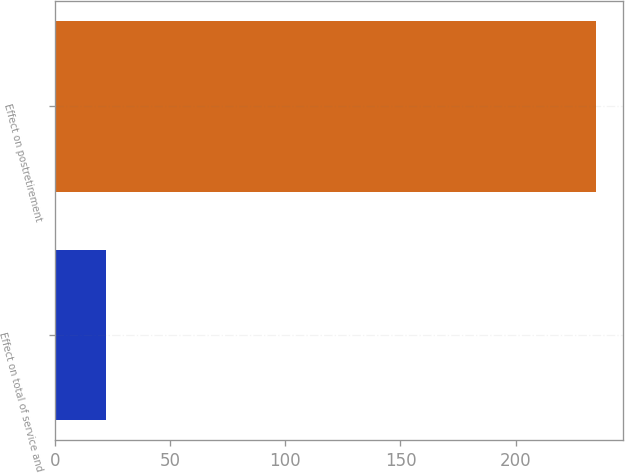<chart> <loc_0><loc_0><loc_500><loc_500><bar_chart><fcel>Effect on total of service and<fcel>Effect on postretirement<nl><fcel>22<fcel>235<nl></chart> 